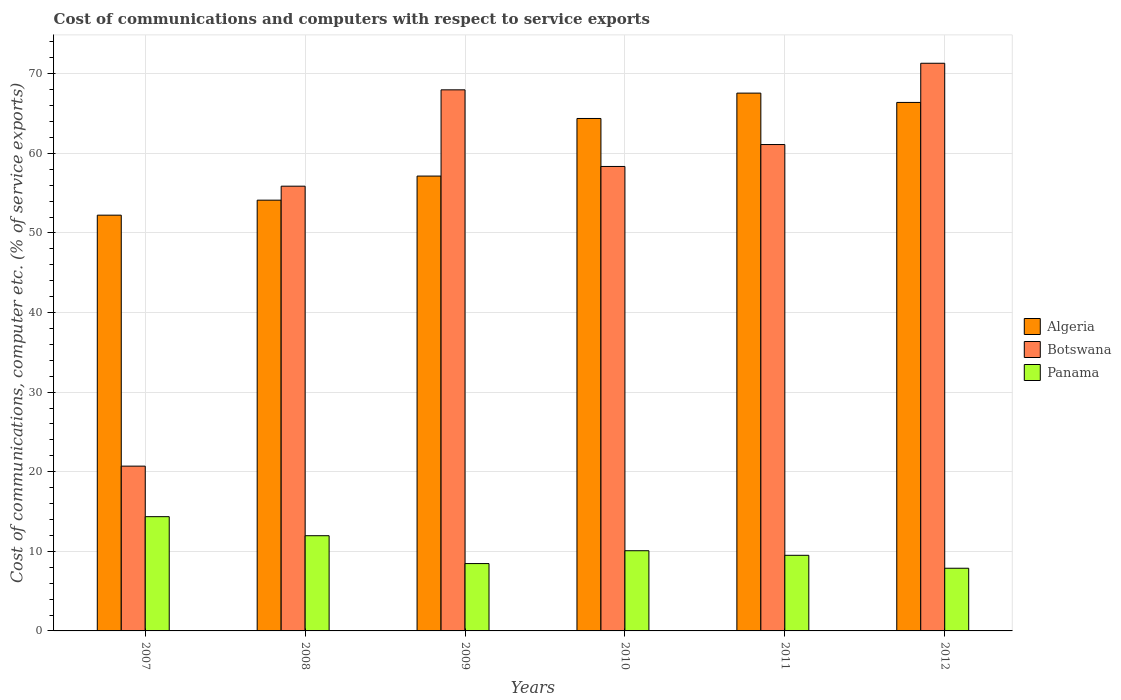How many different coloured bars are there?
Provide a succinct answer. 3. How many groups of bars are there?
Provide a short and direct response. 6. How many bars are there on the 3rd tick from the right?
Keep it short and to the point. 3. What is the label of the 6th group of bars from the left?
Offer a very short reply. 2012. What is the cost of communications and computers in Botswana in 2007?
Make the answer very short. 20.7. Across all years, what is the maximum cost of communications and computers in Algeria?
Your answer should be very brief. 67.57. Across all years, what is the minimum cost of communications and computers in Botswana?
Make the answer very short. 20.7. In which year was the cost of communications and computers in Botswana maximum?
Keep it short and to the point. 2012. In which year was the cost of communications and computers in Panama minimum?
Provide a succinct answer. 2012. What is the total cost of communications and computers in Botswana in the graph?
Offer a terse response. 335.34. What is the difference between the cost of communications and computers in Algeria in 2009 and that in 2010?
Provide a short and direct response. -7.24. What is the difference between the cost of communications and computers in Botswana in 2009 and the cost of communications and computers in Algeria in 2012?
Your response must be concise. 1.58. What is the average cost of communications and computers in Panama per year?
Provide a succinct answer. 10.37. In the year 2009, what is the difference between the cost of communications and computers in Panama and cost of communications and computers in Algeria?
Keep it short and to the point. -48.68. What is the ratio of the cost of communications and computers in Algeria in 2009 to that in 2011?
Give a very brief answer. 0.85. Is the cost of communications and computers in Panama in 2009 less than that in 2011?
Provide a succinct answer. Yes. Is the difference between the cost of communications and computers in Panama in 2009 and 2011 greater than the difference between the cost of communications and computers in Algeria in 2009 and 2011?
Ensure brevity in your answer.  Yes. What is the difference between the highest and the second highest cost of communications and computers in Algeria?
Your answer should be very brief. 1.17. What is the difference between the highest and the lowest cost of communications and computers in Botswana?
Ensure brevity in your answer.  50.62. Is the sum of the cost of communications and computers in Algeria in 2011 and 2012 greater than the maximum cost of communications and computers in Botswana across all years?
Give a very brief answer. Yes. What does the 1st bar from the left in 2008 represents?
Make the answer very short. Algeria. What does the 2nd bar from the right in 2009 represents?
Offer a terse response. Botswana. How many bars are there?
Make the answer very short. 18. Are all the bars in the graph horizontal?
Make the answer very short. No. How many years are there in the graph?
Offer a terse response. 6. Are the values on the major ticks of Y-axis written in scientific E-notation?
Provide a short and direct response. No. Where does the legend appear in the graph?
Give a very brief answer. Center right. How many legend labels are there?
Keep it short and to the point. 3. What is the title of the graph?
Provide a short and direct response. Cost of communications and computers with respect to service exports. What is the label or title of the Y-axis?
Your answer should be very brief. Cost of communications, computer etc. (% of service exports). What is the Cost of communications, computer etc. (% of service exports) of Algeria in 2007?
Provide a short and direct response. 52.24. What is the Cost of communications, computer etc. (% of service exports) in Botswana in 2007?
Offer a terse response. 20.7. What is the Cost of communications, computer etc. (% of service exports) in Panama in 2007?
Your answer should be compact. 14.35. What is the Cost of communications, computer etc. (% of service exports) of Algeria in 2008?
Give a very brief answer. 54.12. What is the Cost of communications, computer etc. (% of service exports) of Botswana in 2008?
Your answer should be compact. 55.88. What is the Cost of communications, computer etc. (% of service exports) of Panama in 2008?
Give a very brief answer. 11.96. What is the Cost of communications, computer etc. (% of service exports) of Algeria in 2009?
Make the answer very short. 57.15. What is the Cost of communications, computer etc. (% of service exports) in Botswana in 2009?
Give a very brief answer. 67.98. What is the Cost of communications, computer etc. (% of service exports) of Panama in 2009?
Offer a terse response. 8.46. What is the Cost of communications, computer etc. (% of service exports) of Algeria in 2010?
Make the answer very short. 64.38. What is the Cost of communications, computer etc. (% of service exports) in Botswana in 2010?
Make the answer very short. 58.35. What is the Cost of communications, computer etc. (% of service exports) of Panama in 2010?
Keep it short and to the point. 10.07. What is the Cost of communications, computer etc. (% of service exports) of Algeria in 2011?
Your answer should be compact. 67.57. What is the Cost of communications, computer etc. (% of service exports) in Botswana in 2011?
Your response must be concise. 61.11. What is the Cost of communications, computer etc. (% of service exports) of Panama in 2011?
Give a very brief answer. 9.5. What is the Cost of communications, computer etc. (% of service exports) in Algeria in 2012?
Keep it short and to the point. 66.4. What is the Cost of communications, computer etc. (% of service exports) in Botswana in 2012?
Ensure brevity in your answer.  71.32. What is the Cost of communications, computer etc. (% of service exports) in Panama in 2012?
Your answer should be very brief. 7.87. Across all years, what is the maximum Cost of communications, computer etc. (% of service exports) of Algeria?
Provide a succinct answer. 67.57. Across all years, what is the maximum Cost of communications, computer etc. (% of service exports) of Botswana?
Your answer should be compact. 71.32. Across all years, what is the maximum Cost of communications, computer etc. (% of service exports) in Panama?
Provide a succinct answer. 14.35. Across all years, what is the minimum Cost of communications, computer etc. (% of service exports) of Algeria?
Make the answer very short. 52.24. Across all years, what is the minimum Cost of communications, computer etc. (% of service exports) of Botswana?
Give a very brief answer. 20.7. Across all years, what is the minimum Cost of communications, computer etc. (% of service exports) of Panama?
Give a very brief answer. 7.87. What is the total Cost of communications, computer etc. (% of service exports) in Algeria in the graph?
Ensure brevity in your answer.  361.85. What is the total Cost of communications, computer etc. (% of service exports) of Botswana in the graph?
Keep it short and to the point. 335.34. What is the total Cost of communications, computer etc. (% of service exports) of Panama in the graph?
Provide a short and direct response. 62.23. What is the difference between the Cost of communications, computer etc. (% of service exports) of Algeria in 2007 and that in 2008?
Give a very brief answer. -1.88. What is the difference between the Cost of communications, computer etc. (% of service exports) of Botswana in 2007 and that in 2008?
Your response must be concise. -35.17. What is the difference between the Cost of communications, computer etc. (% of service exports) of Panama in 2007 and that in 2008?
Give a very brief answer. 2.39. What is the difference between the Cost of communications, computer etc. (% of service exports) of Algeria in 2007 and that in 2009?
Provide a succinct answer. -4.91. What is the difference between the Cost of communications, computer etc. (% of service exports) in Botswana in 2007 and that in 2009?
Offer a very short reply. -47.28. What is the difference between the Cost of communications, computer etc. (% of service exports) in Panama in 2007 and that in 2009?
Keep it short and to the point. 5.89. What is the difference between the Cost of communications, computer etc. (% of service exports) of Algeria in 2007 and that in 2010?
Make the answer very short. -12.15. What is the difference between the Cost of communications, computer etc. (% of service exports) of Botswana in 2007 and that in 2010?
Provide a short and direct response. -37.65. What is the difference between the Cost of communications, computer etc. (% of service exports) of Panama in 2007 and that in 2010?
Make the answer very short. 4.28. What is the difference between the Cost of communications, computer etc. (% of service exports) of Algeria in 2007 and that in 2011?
Your answer should be compact. -15.33. What is the difference between the Cost of communications, computer etc. (% of service exports) of Botswana in 2007 and that in 2011?
Keep it short and to the point. -40.4. What is the difference between the Cost of communications, computer etc. (% of service exports) of Panama in 2007 and that in 2011?
Provide a short and direct response. 4.85. What is the difference between the Cost of communications, computer etc. (% of service exports) in Algeria in 2007 and that in 2012?
Provide a short and direct response. -14.16. What is the difference between the Cost of communications, computer etc. (% of service exports) in Botswana in 2007 and that in 2012?
Offer a terse response. -50.62. What is the difference between the Cost of communications, computer etc. (% of service exports) of Panama in 2007 and that in 2012?
Give a very brief answer. 6.48. What is the difference between the Cost of communications, computer etc. (% of service exports) of Algeria in 2008 and that in 2009?
Your answer should be very brief. -3.03. What is the difference between the Cost of communications, computer etc. (% of service exports) in Botswana in 2008 and that in 2009?
Your answer should be compact. -12.11. What is the difference between the Cost of communications, computer etc. (% of service exports) of Panama in 2008 and that in 2009?
Provide a succinct answer. 3.5. What is the difference between the Cost of communications, computer etc. (% of service exports) of Algeria in 2008 and that in 2010?
Your answer should be compact. -10.26. What is the difference between the Cost of communications, computer etc. (% of service exports) of Botswana in 2008 and that in 2010?
Provide a succinct answer. -2.48. What is the difference between the Cost of communications, computer etc. (% of service exports) in Panama in 2008 and that in 2010?
Keep it short and to the point. 1.89. What is the difference between the Cost of communications, computer etc. (% of service exports) in Algeria in 2008 and that in 2011?
Keep it short and to the point. -13.45. What is the difference between the Cost of communications, computer etc. (% of service exports) in Botswana in 2008 and that in 2011?
Provide a succinct answer. -5.23. What is the difference between the Cost of communications, computer etc. (% of service exports) in Panama in 2008 and that in 2011?
Ensure brevity in your answer.  2.46. What is the difference between the Cost of communications, computer etc. (% of service exports) in Algeria in 2008 and that in 2012?
Your answer should be very brief. -12.28. What is the difference between the Cost of communications, computer etc. (% of service exports) of Botswana in 2008 and that in 2012?
Give a very brief answer. -15.44. What is the difference between the Cost of communications, computer etc. (% of service exports) in Panama in 2008 and that in 2012?
Ensure brevity in your answer.  4.09. What is the difference between the Cost of communications, computer etc. (% of service exports) in Algeria in 2009 and that in 2010?
Provide a succinct answer. -7.24. What is the difference between the Cost of communications, computer etc. (% of service exports) in Botswana in 2009 and that in 2010?
Your answer should be very brief. 9.63. What is the difference between the Cost of communications, computer etc. (% of service exports) in Panama in 2009 and that in 2010?
Keep it short and to the point. -1.61. What is the difference between the Cost of communications, computer etc. (% of service exports) of Algeria in 2009 and that in 2011?
Make the answer very short. -10.42. What is the difference between the Cost of communications, computer etc. (% of service exports) in Botswana in 2009 and that in 2011?
Your response must be concise. 6.87. What is the difference between the Cost of communications, computer etc. (% of service exports) of Panama in 2009 and that in 2011?
Offer a very short reply. -1.04. What is the difference between the Cost of communications, computer etc. (% of service exports) in Algeria in 2009 and that in 2012?
Make the answer very short. -9.25. What is the difference between the Cost of communications, computer etc. (% of service exports) in Botswana in 2009 and that in 2012?
Make the answer very short. -3.34. What is the difference between the Cost of communications, computer etc. (% of service exports) in Panama in 2009 and that in 2012?
Your response must be concise. 0.59. What is the difference between the Cost of communications, computer etc. (% of service exports) of Algeria in 2010 and that in 2011?
Give a very brief answer. -3.19. What is the difference between the Cost of communications, computer etc. (% of service exports) of Botswana in 2010 and that in 2011?
Provide a succinct answer. -2.75. What is the difference between the Cost of communications, computer etc. (% of service exports) of Panama in 2010 and that in 2011?
Ensure brevity in your answer.  0.57. What is the difference between the Cost of communications, computer etc. (% of service exports) of Algeria in 2010 and that in 2012?
Your answer should be compact. -2.02. What is the difference between the Cost of communications, computer etc. (% of service exports) in Botswana in 2010 and that in 2012?
Your answer should be compact. -12.97. What is the difference between the Cost of communications, computer etc. (% of service exports) in Panama in 2010 and that in 2012?
Your answer should be compact. 2.2. What is the difference between the Cost of communications, computer etc. (% of service exports) in Algeria in 2011 and that in 2012?
Keep it short and to the point. 1.17. What is the difference between the Cost of communications, computer etc. (% of service exports) in Botswana in 2011 and that in 2012?
Ensure brevity in your answer.  -10.21. What is the difference between the Cost of communications, computer etc. (% of service exports) of Panama in 2011 and that in 2012?
Provide a succinct answer. 1.63. What is the difference between the Cost of communications, computer etc. (% of service exports) in Algeria in 2007 and the Cost of communications, computer etc. (% of service exports) in Botswana in 2008?
Ensure brevity in your answer.  -3.64. What is the difference between the Cost of communications, computer etc. (% of service exports) in Algeria in 2007 and the Cost of communications, computer etc. (% of service exports) in Panama in 2008?
Offer a very short reply. 40.27. What is the difference between the Cost of communications, computer etc. (% of service exports) in Botswana in 2007 and the Cost of communications, computer etc. (% of service exports) in Panama in 2008?
Give a very brief answer. 8.74. What is the difference between the Cost of communications, computer etc. (% of service exports) in Algeria in 2007 and the Cost of communications, computer etc. (% of service exports) in Botswana in 2009?
Your response must be concise. -15.75. What is the difference between the Cost of communications, computer etc. (% of service exports) in Algeria in 2007 and the Cost of communications, computer etc. (% of service exports) in Panama in 2009?
Give a very brief answer. 43.77. What is the difference between the Cost of communications, computer etc. (% of service exports) of Botswana in 2007 and the Cost of communications, computer etc. (% of service exports) of Panama in 2009?
Give a very brief answer. 12.24. What is the difference between the Cost of communications, computer etc. (% of service exports) in Algeria in 2007 and the Cost of communications, computer etc. (% of service exports) in Botswana in 2010?
Keep it short and to the point. -6.12. What is the difference between the Cost of communications, computer etc. (% of service exports) in Algeria in 2007 and the Cost of communications, computer etc. (% of service exports) in Panama in 2010?
Provide a short and direct response. 42.16. What is the difference between the Cost of communications, computer etc. (% of service exports) in Botswana in 2007 and the Cost of communications, computer etc. (% of service exports) in Panama in 2010?
Offer a terse response. 10.63. What is the difference between the Cost of communications, computer etc. (% of service exports) in Algeria in 2007 and the Cost of communications, computer etc. (% of service exports) in Botswana in 2011?
Your answer should be compact. -8.87. What is the difference between the Cost of communications, computer etc. (% of service exports) in Algeria in 2007 and the Cost of communications, computer etc. (% of service exports) in Panama in 2011?
Provide a succinct answer. 42.73. What is the difference between the Cost of communications, computer etc. (% of service exports) in Botswana in 2007 and the Cost of communications, computer etc. (% of service exports) in Panama in 2011?
Your answer should be very brief. 11.2. What is the difference between the Cost of communications, computer etc. (% of service exports) in Algeria in 2007 and the Cost of communications, computer etc. (% of service exports) in Botswana in 2012?
Offer a terse response. -19.09. What is the difference between the Cost of communications, computer etc. (% of service exports) in Algeria in 2007 and the Cost of communications, computer etc. (% of service exports) in Panama in 2012?
Give a very brief answer. 44.36. What is the difference between the Cost of communications, computer etc. (% of service exports) in Botswana in 2007 and the Cost of communications, computer etc. (% of service exports) in Panama in 2012?
Your answer should be very brief. 12.83. What is the difference between the Cost of communications, computer etc. (% of service exports) in Algeria in 2008 and the Cost of communications, computer etc. (% of service exports) in Botswana in 2009?
Your response must be concise. -13.86. What is the difference between the Cost of communications, computer etc. (% of service exports) in Algeria in 2008 and the Cost of communications, computer etc. (% of service exports) in Panama in 2009?
Ensure brevity in your answer.  45.66. What is the difference between the Cost of communications, computer etc. (% of service exports) in Botswana in 2008 and the Cost of communications, computer etc. (% of service exports) in Panama in 2009?
Your answer should be very brief. 47.41. What is the difference between the Cost of communications, computer etc. (% of service exports) in Algeria in 2008 and the Cost of communications, computer etc. (% of service exports) in Botswana in 2010?
Provide a succinct answer. -4.23. What is the difference between the Cost of communications, computer etc. (% of service exports) in Algeria in 2008 and the Cost of communications, computer etc. (% of service exports) in Panama in 2010?
Offer a terse response. 44.04. What is the difference between the Cost of communications, computer etc. (% of service exports) of Botswana in 2008 and the Cost of communications, computer etc. (% of service exports) of Panama in 2010?
Give a very brief answer. 45.8. What is the difference between the Cost of communications, computer etc. (% of service exports) of Algeria in 2008 and the Cost of communications, computer etc. (% of service exports) of Botswana in 2011?
Provide a short and direct response. -6.99. What is the difference between the Cost of communications, computer etc. (% of service exports) in Algeria in 2008 and the Cost of communications, computer etc. (% of service exports) in Panama in 2011?
Keep it short and to the point. 44.62. What is the difference between the Cost of communications, computer etc. (% of service exports) of Botswana in 2008 and the Cost of communications, computer etc. (% of service exports) of Panama in 2011?
Your answer should be compact. 46.37. What is the difference between the Cost of communications, computer etc. (% of service exports) in Algeria in 2008 and the Cost of communications, computer etc. (% of service exports) in Botswana in 2012?
Give a very brief answer. -17.2. What is the difference between the Cost of communications, computer etc. (% of service exports) in Algeria in 2008 and the Cost of communications, computer etc. (% of service exports) in Panama in 2012?
Your answer should be compact. 46.24. What is the difference between the Cost of communications, computer etc. (% of service exports) in Botswana in 2008 and the Cost of communications, computer etc. (% of service exports) in Panama in 2012?
Offer a terse response. 48. What is the difference between the Cost of communications, computer etc. (% of service exports) in Algeria in 2009 and the Cost of communications, computer etc. (% of service exports) in Botswana in 2010?
Make the answer very short. -1.21. What is the difference between the Cost of communications, computer etc. (% of service exports) in Algeria in 2009 and the Cost of communications, computer etc. (% of service exports) in Panama in 2010?
Offer a very short reply. 47.07. What is the difference between the Cost of communications, computer etc. (% of service exports) in Botswana in 2009 and the Cost of communications, computer etc. (% of service exports) in Panama in 2010?
Keep it short and to the point. 57.91. What is the difference between the Cost of communications, computer etc. (% of service exports) in Algeria in 2009 and the Cost of communications, computer etc. (% of service exports) in Botswana in 2011?
Provide a succinct answer. -3.96. What is the difference between the Cost of communications, computer etc. (% of service exports) of Algeria in 2009 and the Cost of communications, computer etc. (% of service exports) of Panama in 2011?
Your response must be concise. 47.65. What is the difference between the Cost of communications, computer etc. (% of service exports) of Botswana in 2009 and the Cost of communications, computer etc. (% of service exports) of Panama in 2011?
Give a very brief answer. 58.48. What is the difference between the Cost of communications, computer etc. (% of service exports) in Algeria in 2009 and the Cost of communications, computer etc. (% of service exports) in Botswana in 2012?
Offer a very short reply. -14.17. What is the difference between the Cost of communications, computer etc. (% of service exports) of Algeria in 2009 and the Cost of communications, computer etc. (% of service exports) of Panama in 2012?
Make the answer very short. 49.27. What is the difference between the Cost of communications, computer etc. (% of service exports) of Botswana in 2009 and the Cost of communications, computer etc. (% of service exports) of Panama in 2012?
Make the answer very short. 60.11. What is the difference between the Cost of communications, computer etc. (% of service exports) in Algeria in 2010 and the Cost of communications, computer etc. (% of service exports) in Botswana in 2011?
Make the answer very short. 3.27. What is the difference between the Cost of communications, computer etc. (% of service exports) in Algeria in 2010 and the Cost of communications, computer etc. (% of service exports) in Panama in 2011?
Your answer should be very brief. 54.88. What is the difference between the Cost of communications, computer etc. (% of service exports) of Botswana in 2010 and the Cost of communications, computer etc. (% of service exports) of Panama in 2011?
Your answer should be very brief. 48.85. What is the difference between the Cost of communications, computer etc. (% of service exports) in Algeria in 2010 and the Cost of communications, computer etc. (% of service exports) in Botswana in 2012?
Provide a succinct answer. -6.94. What is the difference between the Cost of communications, computer etc. (% of service exports) in Algeria in 2010 and the Cost of communications, computer etc. (% of service exports) in Panama in 2012?
Give a very brief answer. 56.51. What is the difference between the Cost of communications, computer etc. (% of service exports) of Botswana in 2010 and the Cost of communications, computer etc. (% of service exports) of Panama in 2012?
Offer a terse response. 50.48. What is the difference between the Cost of communications, computer etc. (% of service exports) in Algeria in 2011 and the Cost of communications, computer etc. (% of service exports) in Botswana in 2012?
Provide a succinct answer. -3.75. What is the difference between the Cost of communications, computer etc. (% of service exports) of Algeria in 2011 and the Cost of communications, computer etc. (% of service exports) of Panama in 2012?
Your response must be concise. 59.69. What is the difference between the Cost of communications, computer etc. (% of service exports) of Botswana in 2011 and the Cost of communications, computer etc. (% of service exports) of Panama in 2012?
Ensure brevity in your answer.  53.23. What is the average Cost of communications, computer etc. (% of service exports) in Algeria per year?
Offer a very short reply. 60.31. What is the average Cost of communications, computer etc. (% of service exports) in Botswana per year?
Your answer should be very brief. 55.89. What is the average Cost of communications, computer etc. (% of service exports) of Panama per year?
Offer a very short reply. 10.37. In the year 2007, what is the difference between the Cost of communications, computer etc. (% of service exports) of Algeria and Cost of communications, computer etc. (% of service exports) of Botswana?
Your answer should be compact. 31.53. In the year 2007, what is the difference between the Cost of communications, computer etc. (% of service exports) of Algeria and Cost of communications, computer etc. (% of service exports) of Panama?
Your answer should be compact. 37.88. In the year 2007, what is the difference between the Cost of communications, computer etc. (% of service exports) in Botswana and Cost of communications, computer etc. (% of service exports) in Panama?
Ensure brevity in your answer.  6.35. In the year 2008, what is the difference between the Cost of communications, computer etc. (% of service exports) of Algeria and Cost of communications, computer etc. (% of service exports) of Botswana?
Offer a very short reply. -1.76. In the year 2008, what is the difference between the Cost of communications, computer etc. (% of service exports) in Algeria and Cost of communications, computer etc. (% of service exports) in Panama?
Offer a very short reply. 42.16. In the year 2008, what is the difference between the Cost of communications, computer etc. (% of service exports) in Botswana and Cost of communications, computer etc. (% of service exports) in Panama?
Give a very brief answer. 43.91. In the year 2009, what is the difference between the Cost of communications, computer etc. (% of service exports) of Algeria and Cost of communications, computer etc. (% of service exports) of Botswana?
Make the answer very short. -10.83. In the year 2009, what is the difference between the Cost of communications, computer etc. (% of service exports) of Algeria and Cost of communications, computer etc. (% of service exports) of Panama?
Your answer should be very brief. 48.69. In the year 2009, what is the difference between the Cost of communications, computer etc. (% of service exports) in Botswana and Cost of communications, computer etc. (% of service exports) in Panama?
Make the answer very short. 59.52. In the year 2010, what is the difference between the Cost of communications, computer etc. (% of service exports) in Algeria and Cost of communications, computer etc. (% of service exports) in Botswana?
Your response must be concise. 6.03. In the year 2010, what is the difference between the Cost of communications, computer etc. (% of service exports) of Algeria and Cost of communications, computer etc. (% of service exports) of Panama?
Keep it short and to the point. 54.31. In the year 2010, what is the difference between the Cost of communications, computer etc. (% of service exports) in Botswana and Cost of communications, computer etc. (% of service exports) in Panama?
Give a very brief answer. 48.28. In the year 2011, what is the difference between the Cost of communications, computer etc. (% of service exports) of Algeria and Cost of communications, computer etc. (% of service exports) of Botswana?
Make the answer very short. 6.46. In the year 2011, what is the difference between the Cost of communications, computer etc. (% of service exports) in Algeria and Cost of communications, computer etc. (% of service exports) in Panama?
Offer a very short reply. 58.07. In the year 2011, what is the difference between the Cost of communications, computer etc. (% of service exports) of Botswana and Cost of communications, computer etc. (% of service exports) of Panama?
Make the answer very short. 51.61. In the year 2012, what is the difference between the Cost of communications, computer etc. (% of service exports) of Algeria and Cost of communications, computer etc. (% of service exports) of Botswana?
Provide a succinct answer. -4.92. In the year 2012, what is the difference between the Cost of communications, computer etc. (% of service exports) of Algeria and Cost of communications, computer etc. (% of service exports) of Panama?
Your response must be concise. 58.52. In the year 2012, what is the difference between the Cost of communications, computer etc. (% of service exports) in Botswana and Cost of communications, computer etc. (% of service exports) in Panama?
Give a very brief answer. 63.45. What is the ratio of the Cost of communications, computer etc. (% of service exports) in Algeria in 2007 to that in 2008?
Provide a short and direct response. 0.97. What is the ratio of the Cost of communications, computer etc. (% of service exports) of Botswana in 2007 to that in 2008?
Provide a short and direct response. 0.37. What is the ratio of the Cost of communications, computer etc. (% of service exports) of Panama in 2007 to that in 2008?
Make the answer very short. 1.2. What is the ratio of the Cost of communications, computer etc. (% of service exports) in Algeria in 2007 to that in 2009?
Your response must be concise. 0.91. What is the ratio of the Cost of communications, computer etc. (% of service exports) of Botswana in 2007 to that in 2009?
Offer a terse response. 0.3. What is the ratio of the Cost of communications, computer etc. (% of service exports) in Panama in 2007 to that in 2009?
Offer a very short reply. 1.7. What is the ratio of the Cost of communications, computer etc. (% of service exports) of Algeria in 2007 to that in 2010?
Ensure brevity in your answer.  0.81. What is the ratio of the Cost of communications, computer etc. (% of service exports) in Botswana in 2007 to that in 2010?
Your answer should be very brief. 0.35. What is the ratio of the Cost of communications, computer etc. (% of service exports) of Panama in 2007 to that in 2010?
Ensure brevity in your answer.  1.42. What is the ratio of the Cost of communications, computer etc. (% of service exports) in Algeria in 2007 to that in 2011?
Your answer should be compact. 0.77. What is the ratio of the Cost of communications, computer etc. (% of service exports) of Botswana in 2007 to that in 2011?
Your answer should be very brief. 0.34. What is the ratio of the Cost of communications, computer etc. (% of service exports) in Panama in 2007 to that in 2011?
Provide a succinct answer. 1.51. What is the ratio of the Cost of communications, computer etc. (% of service exports) in Algeria in 2007 to that in 2012?
Ensure brevity in your answer.  0.79. What is the ratio of the Cost of communications, computer etc. (% of service exports) of Botswana in 2007 to that in 2012?
Provide a short and direct response. 0.29. What is the ratio of the Cost of communications, computer etc. (% of service exports) of Panama in 2007 to that in 2012?
Your response must be concise. 1.82. What is the ratio of the Cost of communications, computer etc. (% of service exports) in Algeria in 2008 to that in 2009?
Give a very brief answer. 0.95. What is the ratio of the Cost of communications, computer etc. (% of service exports) in Botswana in 2008 to that in 2009?
Keep it short and to the point. 0.82. What is the ratio of the Cost of communications, computer etc. (% of service exports) of Panama in 2008 to that in 2009?
Offer a terse response. 1.41. What is the ratio of the Cost of communications, computer etc. (% of service exports) in Algeria in 2008 to that in 2010?
Keep it short and to the point. 0.84. What is the ratio of the Cost of communications, computer etc. (% of service exports) in Botswana in 2008 to that in 2010?
Your answer should be compact. 0.96. What is the ratio of the Cost of communications, computer etc. (% of service exports) of Panama in 2008 to that in 2010?
Your answer should be compact. 1.19. What is the ratio of the Cost of communications, computer etc. (% of service exports) of Algeria in 2008 to that in 2011?
Offer a terse response. 0.8. What is the ratio of the Cost of communications, computer etc. (% of service exports) of Botswana in 2008 to that in 2011?
Your answer should be compact. 0.91. What is the ratio of the Cost of communications, computer etc. (% of service exports) of Panama in 2008 to that in 2011?
Your response must be concise. 1.26. What is the ratio of the Cost of communications, computer etc. (% of service exports) of Algeria in 2008 to that in 2012?
Keep it short and to the point. 0.82. What is the ratio of the Cost of communications, computer etc. (% of service exports) in Botswana in 2008 to that in 2012?
Keep it short and to the point. 0.78. What is the ratio of the Cost of communications, computer etc. (% of service exports) in Panama in 2008 to that in 2012?
Offer a terse response. 1.52. What is the ratio of the Cost of communications, computer etc. (% of service exports) of Algeria in 2009 to that in 2010?
Offer a very short reply. 0.89. What is the ratio of the Cost of communications, computer etc. (% of service exports) in Botswana in 2009 to that in 2010?
Your response must be concise. 1.17. What is the ratio of the Cost of communications, computer etc. (% of service exports) in Panama in 2009 to that in 2010?
Your answer should be compact. 0.84. What is the ratio of the Cost of communications, computer etc. (% of service exports) of Algeria in 2009 to that in 2011?
Offer a very short reply. 0.85. What is the ratio of the Cost of communications, computer etc. (% of service exports) in Botswana in 2009 to that in 2011?
Make the answer very short. 1.11. What is the ratio of the Cost of communications, computer etc. (% of service exports) in Panama in 2009 to that in 2011?
Your answer should be compact. 0.89. What is the ratio of the Cost of communications, computer etc. (% of service exports) of Algeria in 2009 to that in 2012?
Offer a terse response. 0.86. What is the ratio of the Cost of communications, computer etc. (% of service exports) in Botswana in 2009 to that in 2012?
Your answer should be compact. 0.95. What is the ratio of the Cost of communications, computer etc. (% of service exports) in Panama in 2009 to that in 2012?
Provide a short and direct response. 1.07. What is the ratio of the Cost of communications, computer etc. (% of service exports) of Algeria in 2010 to that in 2011?
Your answer should be compact. 0.95. What is the ratio of the Cost of communications, computer etc. (% of service exports) in Botswana in 2010 to that in 2011?
Keep it short and to the point. 0.95. What is the ratio of the Cost of communications, computer etc. (% of service exports) of Panama in 2010 to that in 2011?
Ensure brevity in your answer.  1.06. What is the ratio of the Cost of communications, computer etc. (% of service exports) in Algeria in 2010 to that in 2012?
Keep it short and to the point. 0.97. What is the ratio of the Cost of communications, computer etc. (% of service exports) in Botswana in 2010 to that in 2012?
Give a very brief answer. 0.82. What is the ratio of the Cost of communications, computer etc. (% of service exports) in Panama in 2010 to that in 2012?
Provide a succinct answer. 1.28. What is the ratio of the Cost of communications, computer etc. (% of service exports) in Algeria in 2011 to that in 2012?
Your answer should be compact. 1.02. What is the ratio of the Cost of communications, computer etc. (% of service exports) of Botswana in 2011 to that in 2012?
Keep it short and to the point. 0.86. What is the ratio of the Cost of communications, computer etc. (% of service exports) of Panama in 2011 to that in 2012?
Give a very brief answer. 1.21. What is the difference between the highest and the second highest Cost of communications, computer etc. (% of service exports) in Algeria?
Provide a succinct answer. 1.17. What is the difference between the highest and the second highest Cost of communications, computer etc. (% of service exports) in Botswana?
Your response must be concise. 3.34. What is the difference between the highest and the second highest Cost of communications, computer etc. (% of service exports) of Panama?
Ensure brevity in your answer.  2.39. What is the difference between the highest and the lowest Cost of communications, computer etc. (% of service exports) of Algeria?
Give a very brief answer. 15.33. What is the difference between the highest and the lowest Cost of communications, computer etc. (% of service exports) in Botswana?
Provide a short and direct response. 50.62. What is the difference between the highest and the lowest Cost of communications, computer etc. (% of service exports) in Panama?
Provide a succinct answer. 6.48. 